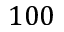Convert formula to latex. <formula><loc_0><loc_0><loc_500><loc_500>1 0 0</formula> 